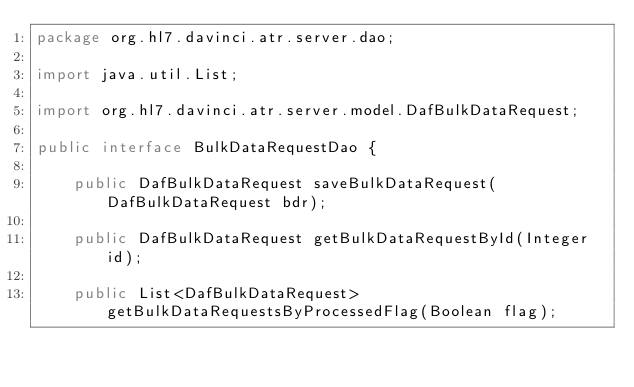Convert code to text. <code><loc_0><loc_0><loc_500><loc_500><_Java_>package org.hl7.davinci.atr.server.dao;

import java.util.List;

import org.hl7.davinci.atr.server.model.DafBulkDataRequest;

public interface BulkDataRequestDao {
	
	public DafBulkDataRequest saveBulkDataRequest(DafBulkDataRequest bdr);
	
	public DafBulkDataRequest getBulkDataRequestById(Integer id);
	
	public List<DafBulkDataRequest> getBulkDataRequestsByProcessedFlag(Boolean flag);
	</code> 